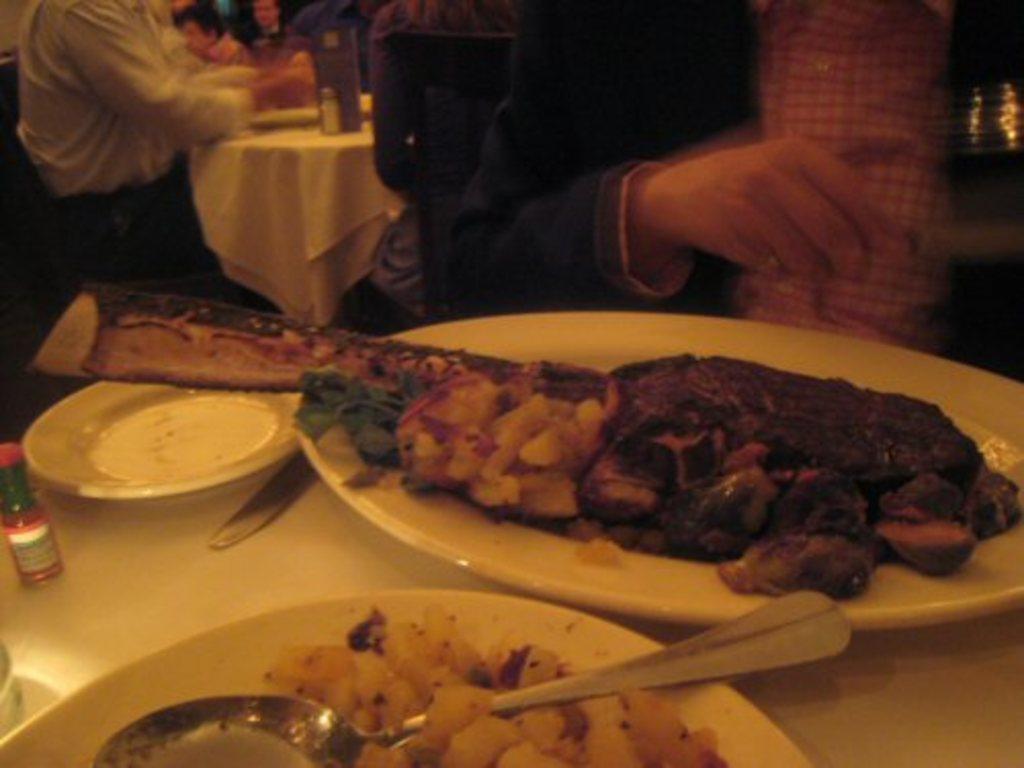Please provide a concise description of this image. In this image we can see some people sitting on chairs. In the foreground of the image we can see some plates containing food, spoons and a bottle placed on the table. 